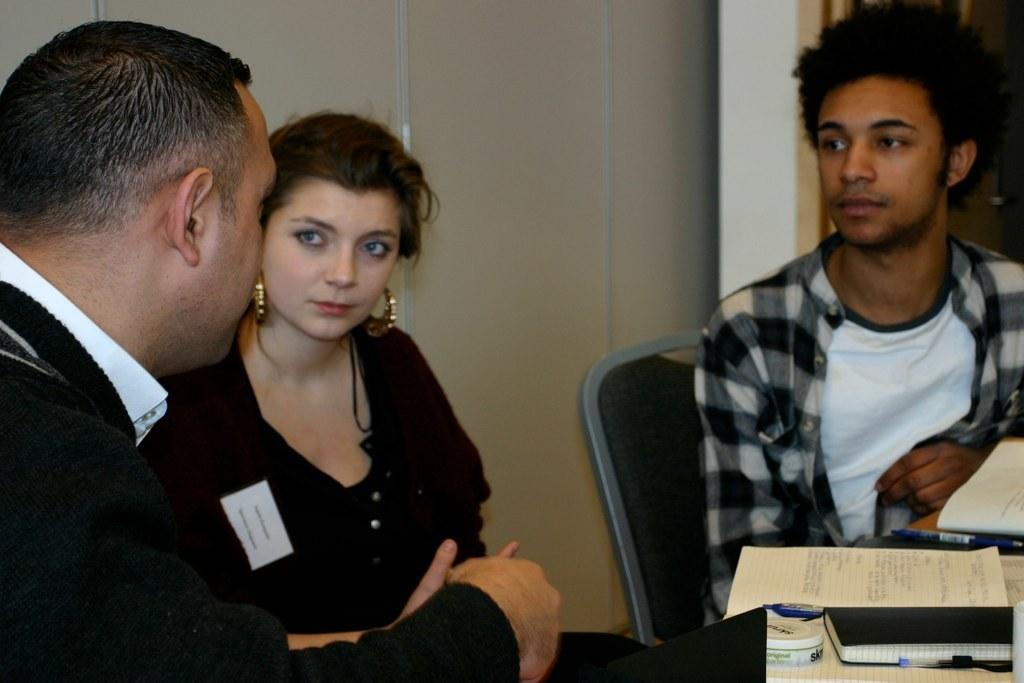What are the people in the image doing? The people in the image are sitting. What writing instruments can be seen in the image? There are pens in the image. What reading materials are present in the image? There are books in the image. Can you describe any other objects in the image? There are unspecified objects in the image. What type of bubble is being traded in the image? There is no bubble or trading activity present in the image. 